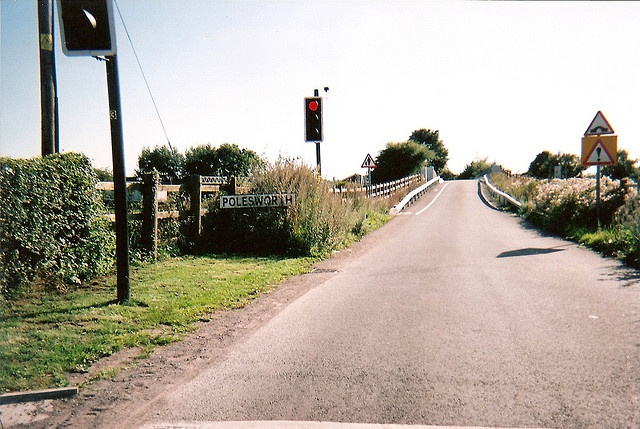Describe the objects in this image and their specific colors. I can see traffic light in darkgray, black, and gray tones and traffic light in darkgray, black, lightgray, and brown tones in this image. 